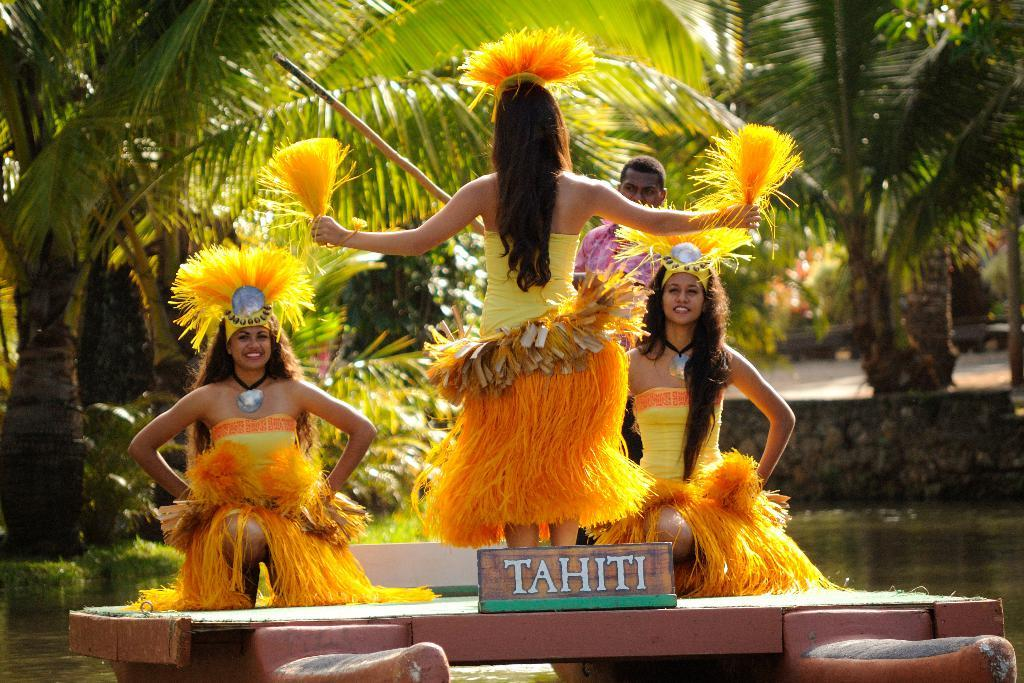What is the main subject of the image? The main subject of the image is people on a boat. Where is the boat located in the image? The boat is in the center of the image. What can be seen in the background of the image? There are trees in the background of the image. What is visible at the bottom of the image? There is water visible at the bottom of the image. What type of arch can be seen in the image? There is no arch present in the image. What is the position of the thing in the image? The question is unclear as there is no "thing" mentioned in the provided facts. 